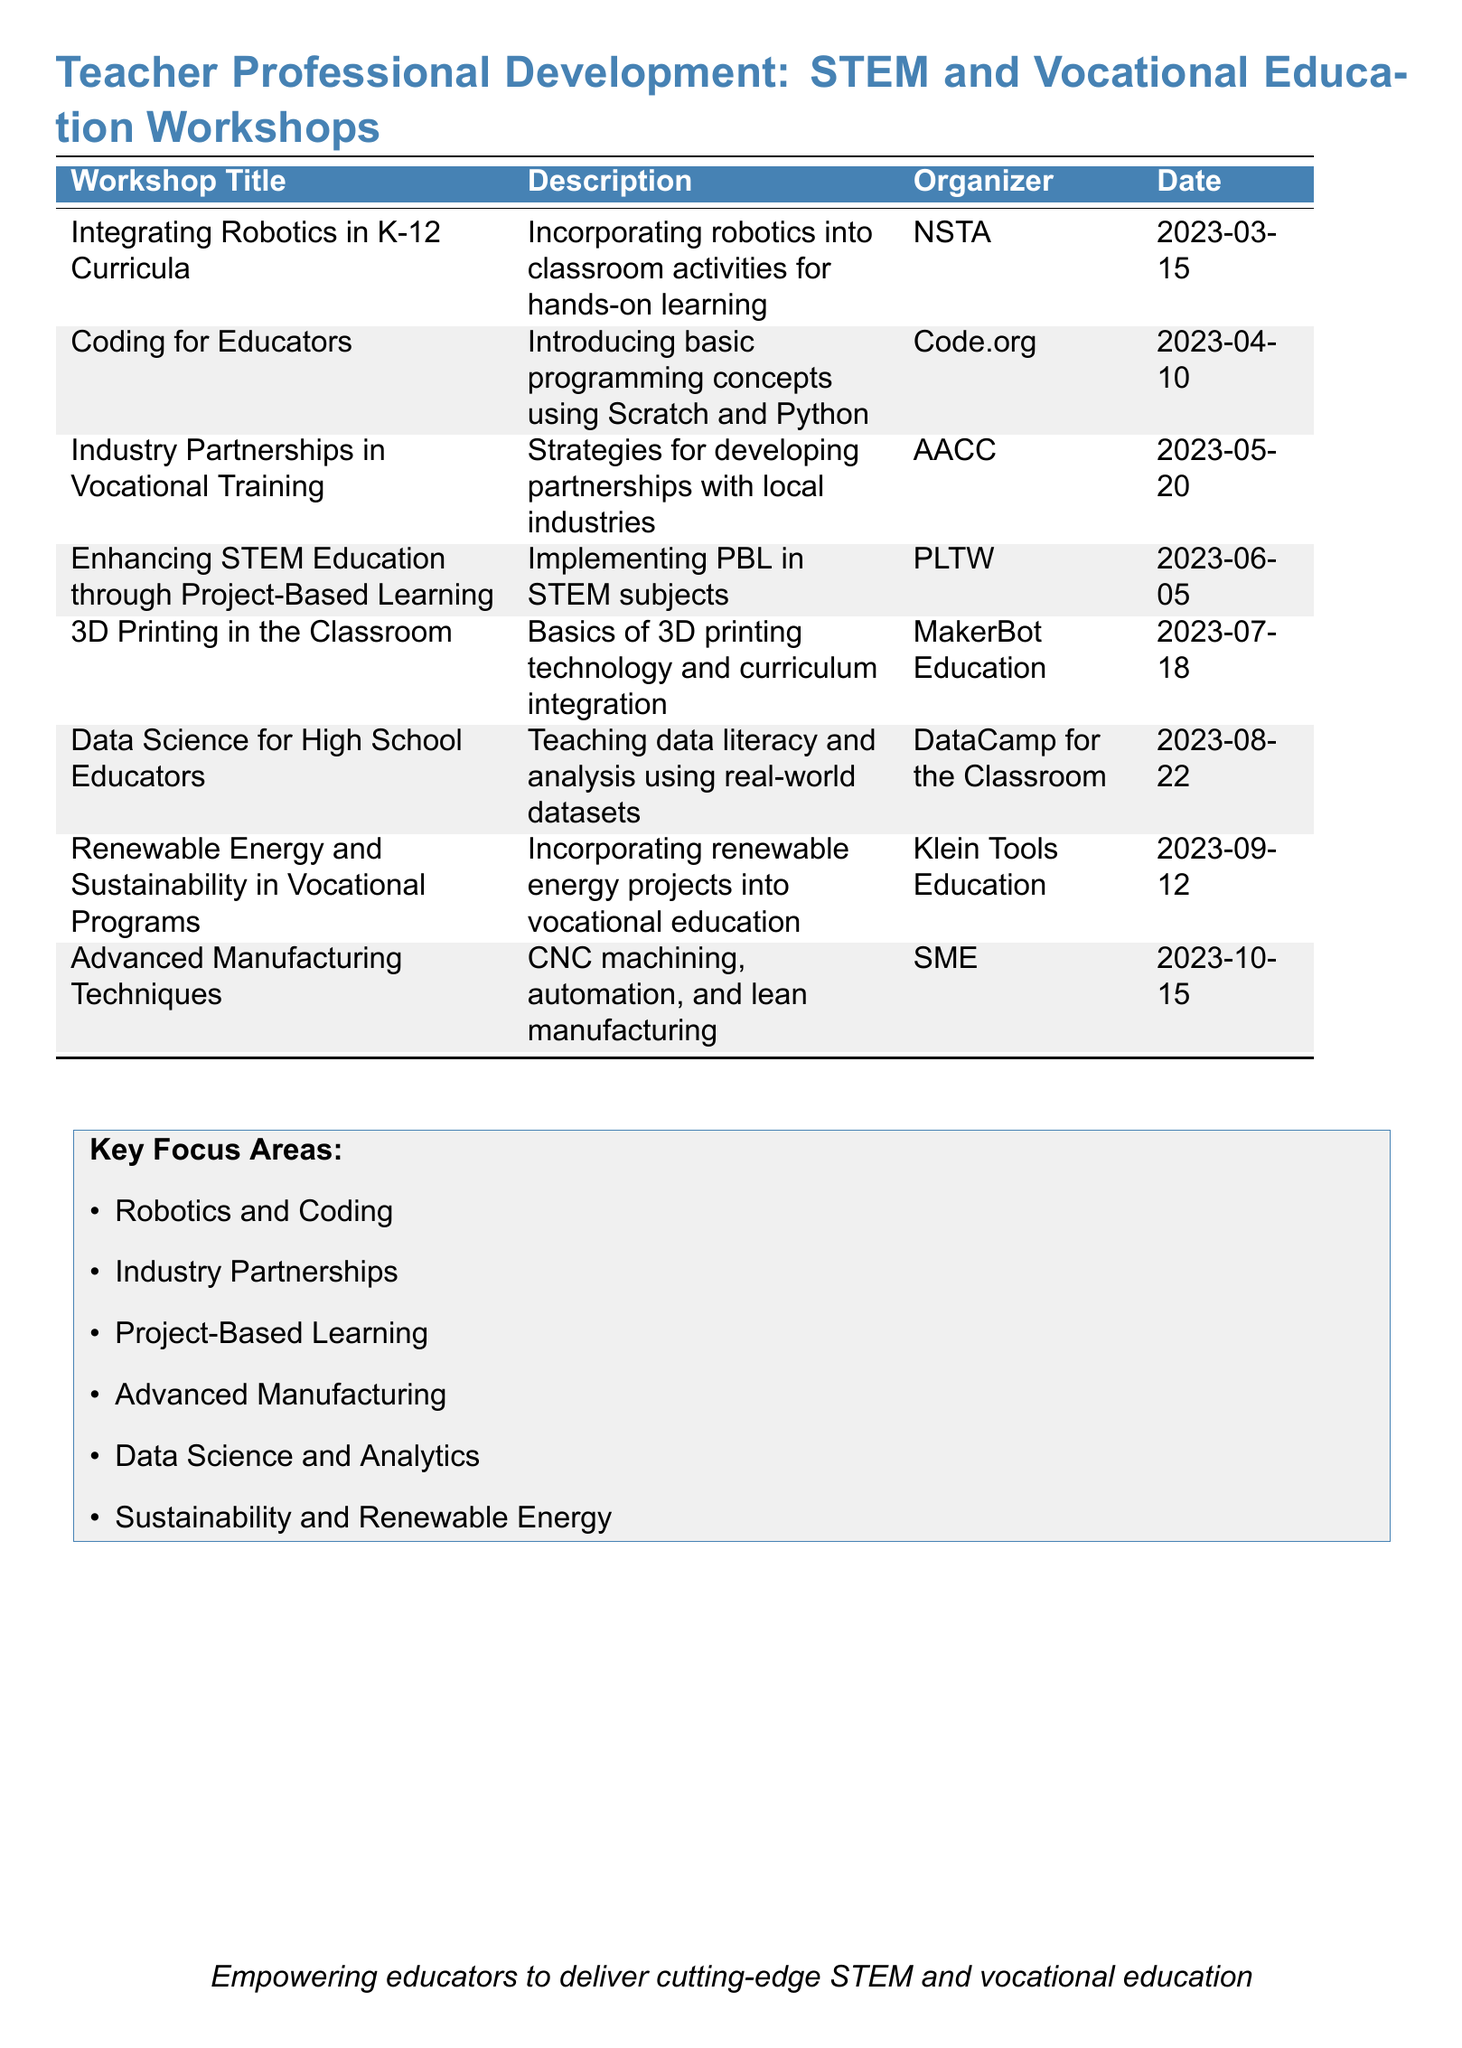what is the title of the workshop focusing on robotics? The title of the workshop is specifically focused on robotics and is listed as "Integrating Robotics in K-12 Curricula."
Answer: Integrating Robotics in K-12 Curricula who organized the "Coding for Educators" workshop? The organizer for the "Coding for Educators" workshop is mentioned in the document, identifying it as Code.org.
Answer: Code.org when is the workshop on "Data Science for High School Educators"? The date for the "Data Science for High School Educators" workshop is given in the document. It is on August 22, 2023.
Answer: 2023-08-22 which workshop is about incorporating renewable energy projects? The document specifically mentions the workshop titled "Renewable Energy and Sustainability in Vocational Programs" that focuses on this topic.
Answer: Renewable Energy and Sustainability in Vocational Programs how many workshops are listed in total? The total number of workshops mentioned in the document is counted to get the complete figure, which is 8.
Answer: 8 which focus area emphasizes Project-Based Learning? The "Enhancing STEM Education through Project-Based Learning" workshop is dedicated to implementing this approach, highlighting its relevance.
Answer: Project-Based Learning what technology is covered in the "3D Printing in the Classroom" workshop? The document identifies that the workshop covers basics of 3D printing technology, making it clear what technology is discussed.
Answer: 3D printing technology what is the purpose of the workshops described in the document? The purpose is summarized by the phrase included at the end of the document, encapsulating the intent behind these workshops.
Answer: Empowering educators to deliver cutting-edge STEM and vocational education 